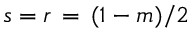<formula> <loc_0><loc_0><loc_500><loc_500>s = r \, = \, ( 1 - m ) / 2</formula> 